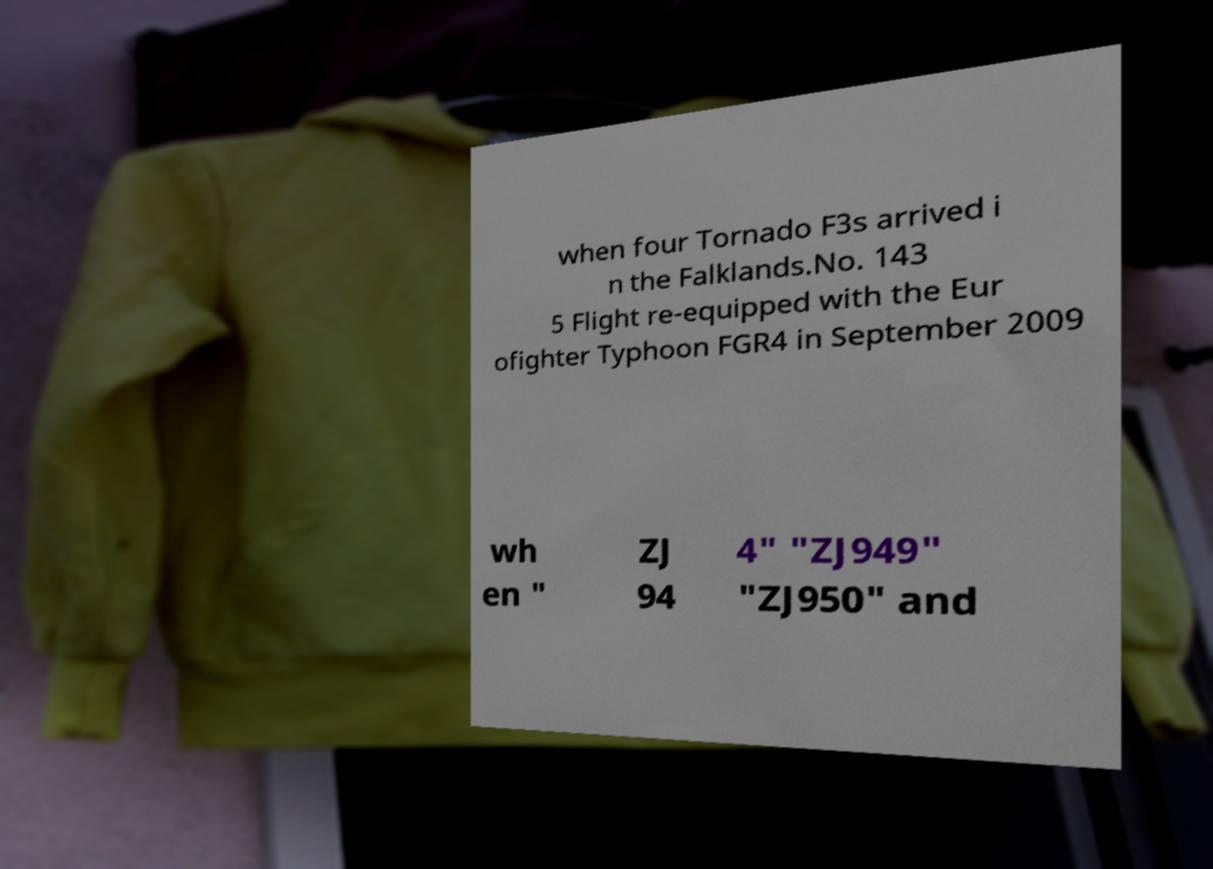Can you read and provide the text displayed in the image?This photo seems to have some interesting text. Can you extract and type it out for me? when four Tornado F3s arrived i n the Falklands.No. 143 5 Flight re-equipped with the Eur ofighter Typhoon FGR4 in September 2009 wh en " ZJ 94 4" "ZJ949" "ZJ950" and 